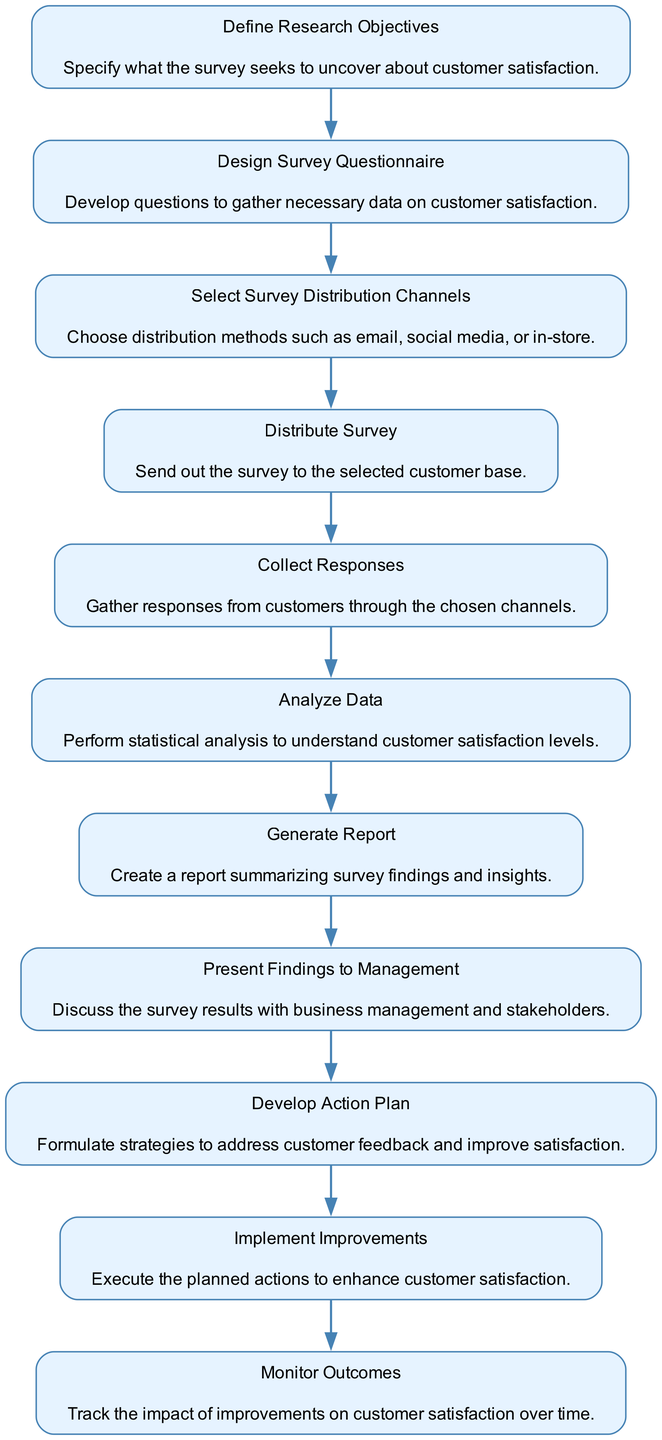What is the first activity in the diagram? The first activity in the diagram is "Define Research Objectives." It is the first node in a sequential flow, indicating that this step must occur before any other activities.
Answer: Define Research Objectives How many nodes are present in the activity diagram? The diagram contains a total of 11 nodes, each representing a specific activity related to the customer satisfaction survey process. Counting each of the activities listed in the data confirms the total number.
Answer: 11 What is the relationship between "Generate Report" and "Analyze Data"? "Generate Report" is directly connected to "Analyze Data," with "Analyze Data" occurring first. The flow indicates that the report can only be generated after data analysis has been completed.
Answer: "Analyze Data" leads to "Generate Report" Which activity follows "Collect Responses"? "Analyze Data" immediately follows "Collect Responses" in the process flow, indicating that data collection must be completed before analysis can begin.
Answer: Analyze Data What is the final activity in the process? The final activity in the diagram is "Monitor Outcomes." This step is positioned at the end of the flow, implying ongoing evaluation after implementing improvements.
Answer: Monitor Outcomes What activity occurs after "Present Findings to Management"? The activity that occurs after "Present Findings to Management" is "Develop Action Plan," which suggests that feedback from management leads to planning actionable steps based on survey results.
Answer: Develop Action Plan How many activities focus on improvement actions based on customer feedback? There are two activities focusing on improvement actions: "Develop Action Plan" and "Implement Improvements." These activities are essential for addressing customer feedback and enhancing satisfaction.
Answer: 2 Which two activities directly lead to implementation actions? The two activities that directly lead to implementation actions are "Develop Action Plan" and "Implement Improvements." They are connected sequentially, highlighting the transition from planning to action.
Answer: Develop Action Plan, Implement Improvements What activity must be completed before distributing the survey? "Design Survey Questionnaire" must be completed before "Distribute Survey." This sequence shows that creating the questionnaire is a prerequisite for sharing it with customers.
Answer: Design Survey Questionnaire 